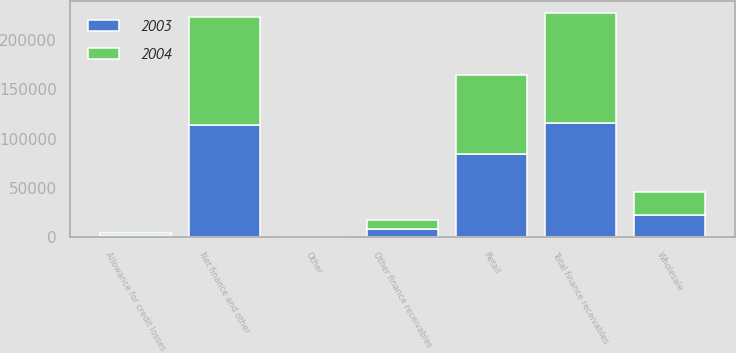<chart> <loc_0><loc_0><loc_500><loc_500><stacked_bar_chart><ecel><fcel>Retail<fcel>Wholesale<fcel>Other finance receivables<fcel>Total finance receivables<fcel>Allowance for credit losses<fcel>Other<fcel>Net finance and other<nl><fcel>2003<fcel>84843<fcel>22666<fcel>8409<fcel>115918<fcel>2166<fcel>72<fcel>113824<nl><fcel>2004<fcel>80017<fcel>22910<fcel>9083<fcel>112010<fcel>2338<fcel>331<fcel>110003<nl></chart> 